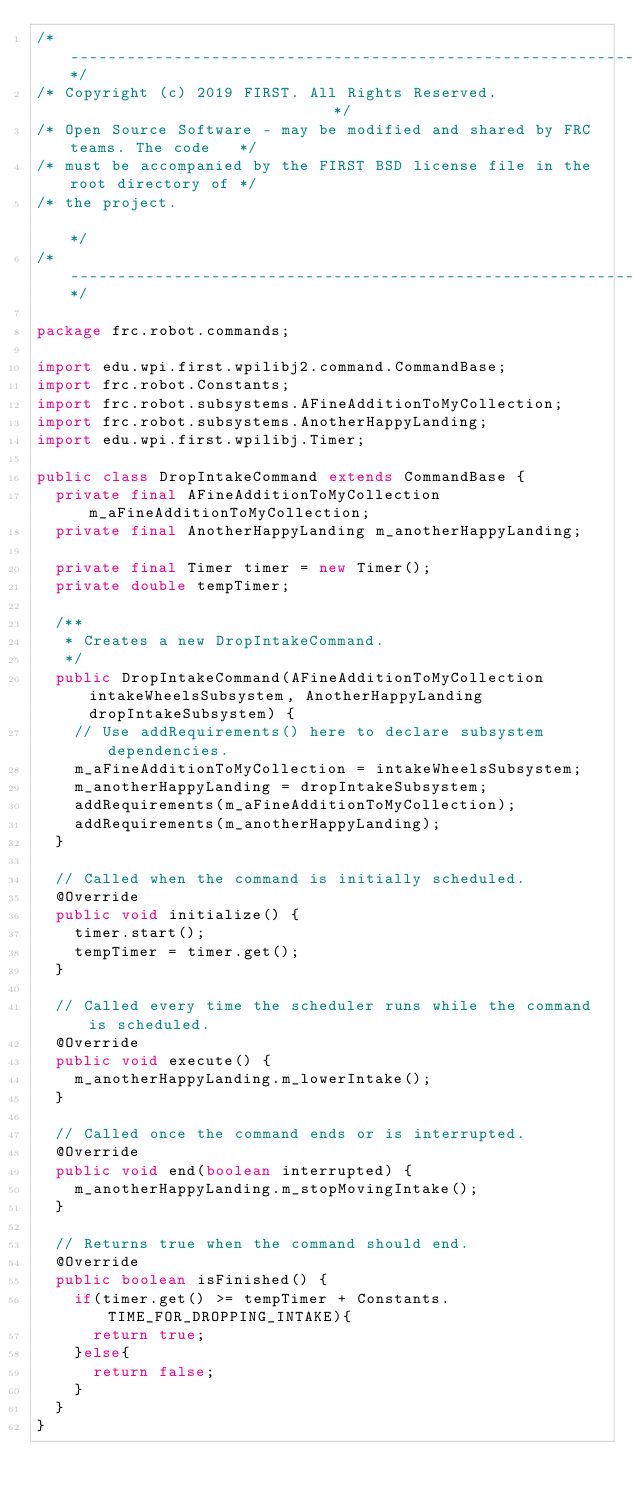Convert code to text. <code><loc_0><loc_0><loc_500><loc_500><_Java_>/*----------------------------------------------------------------------------*/
/* Copyright (c) 2019 FIRST. All Rights Reserved.                             */
/* Open Source Software - may be modified and shared by FRC teams. The code   */
/* must be accompanied by the FIRST BSD license file in the root directory of */
/* the project.                                                               */
/*----------------------------------------------------------------------------*/

package frc.robot.commands;

import edu.wpi.first.wpilibj2.command.CommandBase;
import frc.robot.Constants;
import frc.robot.subsystems.AFineAdditionToMyCollection;
import frc.robot.subsystems.AnotherHappyLanding;
import edu.wpi.first.wpilibj.Timer;

public class DropIntakeCommand extends CommandBase {
  private final AFineAdditionToMyCollection m_aFineAdditionToMyCollection;
  private final AnotherHappyLanding m_anotherHappyLanding;

  private final Timer timer = new Timer();
  private double tempTimer;

  /**
   * Creates a new DropIntakeCommand.
   */
  public DropIntakeCommand(AFineAdditionToMyCollection intakeWheelsSubsystem, AnotherHappyLanding dropIntakeSubsystem) {
    // Use addRequirements() here to declare subsystem dependencies.
    m_aFineAdditionToMyCollection = intakeWheelsSubsystem;
    m_anotherHappyLanding = dropIntakeSubsystem;
    addRequirements(m_aFineAdditionToMyCollection);
    addRequirements(m_anotherHappyLanding);
  }

  // Called when the command is initially scheduled.
  @Override
  public void initialize() {
    timer.start();
    tempTimer = timer.get();
  }

  // Called every time the scheduler runs while the command is scheduled.
  @Override
  public void execute() {
    m_anotherHappyLanding.m_lowerIntake();
  }

  // Called once the command ends or is interrupted.
  @Override
  public void end(boolean interrupted) {
    m_anotherHappyLanding.m_stopMovingIntake();
  }

  // Returns true when the command should end.
  @Override
  public boolean isFinished() {
    if(timer.get() >= tempTimer + Constants.TIME_FOR_DROPPING_INTAKE){
      return true;
    }else{
      return false;
    }
  }
}
</code> 